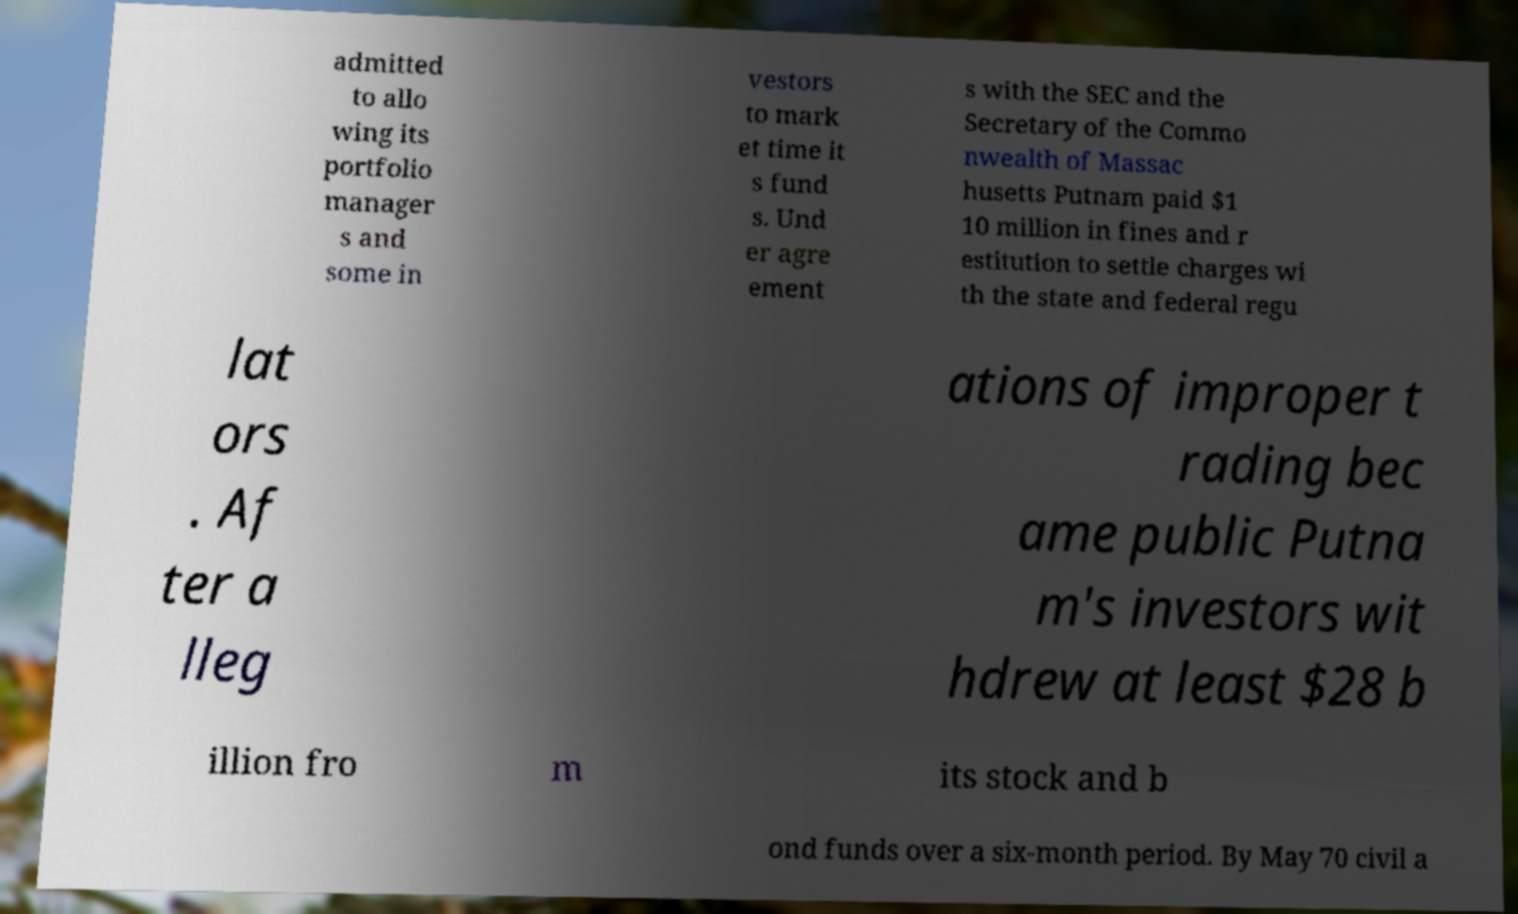Can you read and provide the text displayed in the image?This photo seems to have some interesting text. Can you extract and type it out for me? admitted to allo wing its portfolio manager s and some in vestors to mark et time it s fund s. Und er agre ement s with the SEC and the Secretary of the Commo nwealth of Massac husetts Putnam paid $1 10 million in fines and r estitution to settle charges wi th the state and federal regu lat ors . Af ter a lleg ations of improper t rading bec ame public Putna m's investors wit hdrew at least $28 b illion fro m its stock and b ond funds over a six-month period. By May 70 civil a 